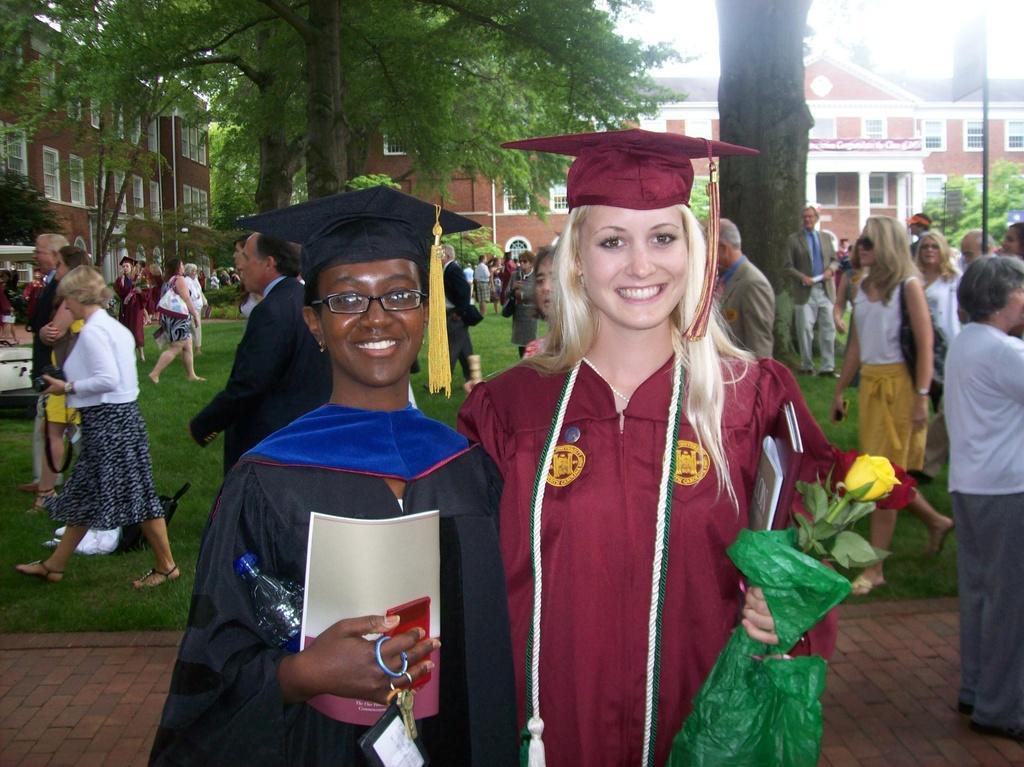Please provide a concise description of this image. In this picture we can see two women wearing hats and holding objects in their hands. These women are standing and smiling. We can see a few people, trees, poles, buildings, some grass on the ground and other objects. 